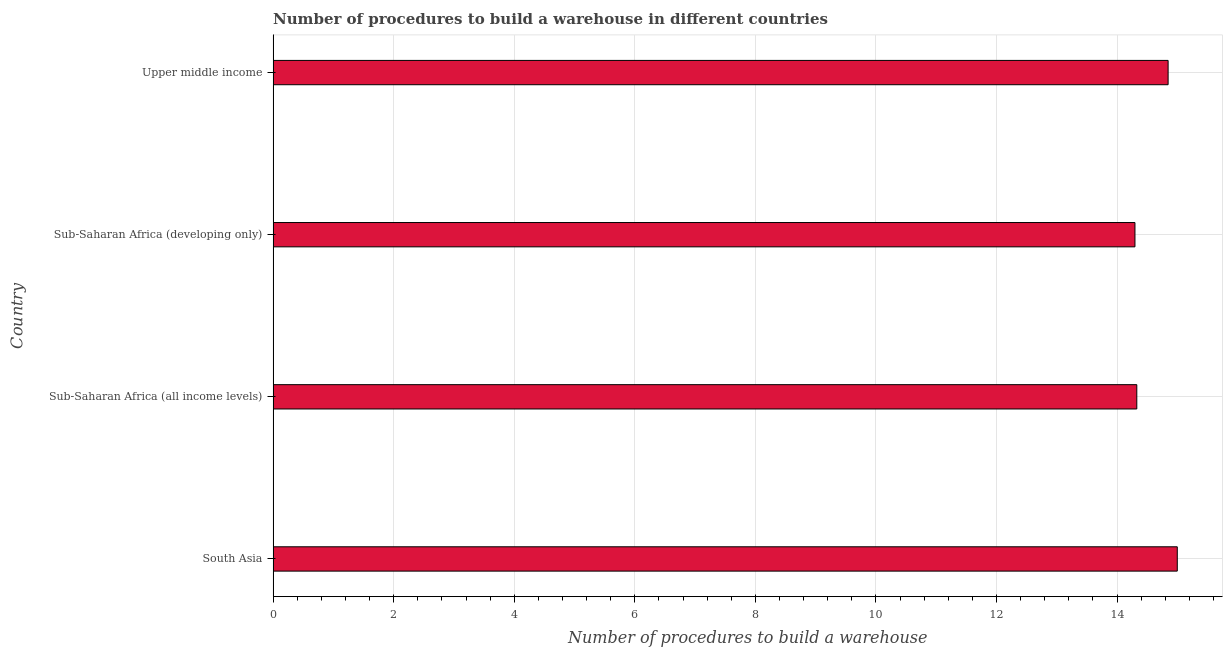Does the graph contain any zero values?
Offer a very short reply. No. What is the title of the graph?
Your answer should be compact. Number of procedures to build a warehouse in different countries. What is the label or title of the X-axis?
Offer a very short reply. Number of procedures to build a warehouse. What is the number of procedures to build a warehouse in Sub-Saharan Africa (all income levels)?
Keep it short and to the point. 14.33. Across all countries, what is the minimum number of procedures to build a warehouse?
Make the answer very short. 14.3. In which country was the number of procedures to build a warehouse minimum?
Make the answer very short. Sub-Saharan Africa (developing only). What is the sum of the number of procedures to build a warehouse?
Offer a very short reply. 58.47. What is the difference between the number of procedures to build a warehouse in Sub-Saharan Africa (developing only) and Upper middle income?
Your answer should be very brief. -0.55. What is the average number of procedures to build a warehouse per country?
Make the answer very short. 14.62. What is the median number of procedures to build a warehouse?
Ensure brevity in your answer.  14.59. In how many countries, is the number of procedures to build a warehouse greater than 4 ?
Offer a terse response. 4. What is the ratio of the number of procedures to build a warehouse in South Asia to that in Sub-Saharan Africa (developing only)?
Your answer should be compact. 1.05. Is the number of procedures to build a warehouse in Sub-Saharan Africa (developing only) less than that in Upper middle income?
Make the answer very short. Yes. Is the difference between the number of procedures to build a warehouse in South Asia and Sub-Saharan Africa (developing only) greater than the difference between any two countries?
Offer a terse response. Yes. What is the difference between the highest and the second highest number of procedures to build a warehouse?
Your response must be concise. 0.15. Is the sum of the number of procedures to build a warehouse in South Asia and Sub-Saharan Africa (all income levels) greater than the maximum number of procedures to build a warehouse across all countries?
Make the answer very short. Yes. In how many countries, is the number of procedures to build a warehouse greater than the average number of procedures to build a warehouse taken over all countries?
Offer a very short reply. 2. How many countries are there in the graph?
Ensure brevity in your answer.  4. What is the difference between two consecutive major ticks on the X-axis?
Provide a succinct answer. 2. Are the values on the major ticks of X-axis written in scientific E-notation?
Your answer should be compact. No. What is the Number of procedures to build a warehouse in Sub-Saharan Africa (all income levels)?
Ensure brevity in your answer.  14.33. What is the Number of procedures to build a warehouse of Sub-Saharan Africa (developing only)?
Your response must be concise. 14.3. What is the Number of procedures to build a warehouse of Upper middle income?
Offer a very short reply. 14.85. What is the difference between the Number of procedures to build a warehouse in South Asia and Sub-Saharan Africa (all income levels)?
Keep it short and to the point. 0.67. What is the difference between the Number of procedures to build a warehouse in South Asia and Sub-Saharan Africa (developing only)?
Your answer should be compact. 0.7. What is the difference between the Number of procedures to build a warehouse in South Asia and Upper middle income?
Provide a short and direct response. 0.15. What is the difference between the Number of procedures to build a warehouse in Sub-Saharan Africa (all income levels) and Sub-Saharan Africa (developing only)?
Your response must be concise. 0.03. What is the difference between the Number of procedures to build a warehouse in Sub-Saharan Africa (all income levels) and Upper middle income?
Offer a very short reply. -0.52. What is the difference between the Number of procedures to build a warehouse in Sub-Saharan Africa (developing only) and Upper middle income?
Ensure brevity in your answer.  -0.55. What is the ratio of the Number of procedures to build a warehouse in South Asia to that in Sub-Saharan Africa (all income levels)?
Your answer should be compact. 1.05. What is the ratio of the Number of procedures to build a warehouse in South Asia to that in Sub-Saharan Africa (developing only)?
Provide a succinct answer. 1.05. What is the ratio of the Number of procedures to build a warehouse in South Asia to that in Upper middle income?
Give a very brief answer. 1.01. What is the ratio of the Number of procedures to build a warehouse in Sub-Saharan Africa (all income levels) to that in Upper middle income?
Make the answer very short. 0.96. 